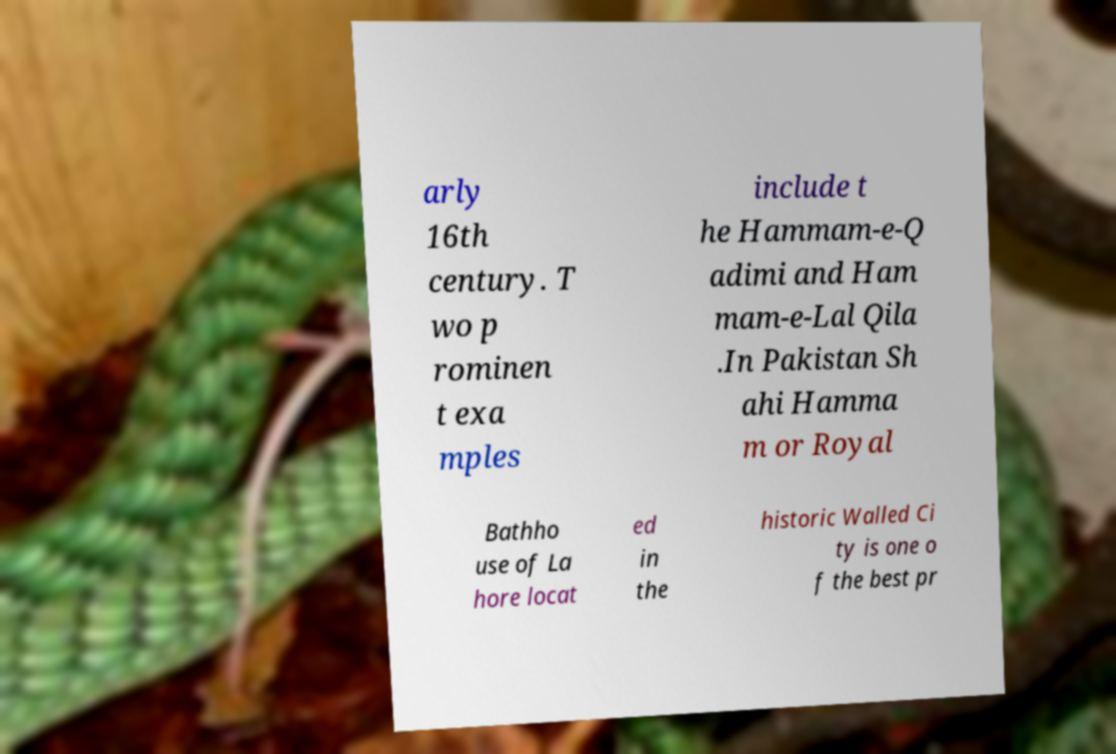Please read and relay the text visible in this image. What does it say? arly 16th century. T wo p rominen t exa mples include t he Hammam-e-Q adimi and Ham mam-e-Lal Qila .In Pakistan Sh ahi Hamma m or Royal Bathho use of La hore locat ed in the historic Walled Ci ty is one o f the best pr 